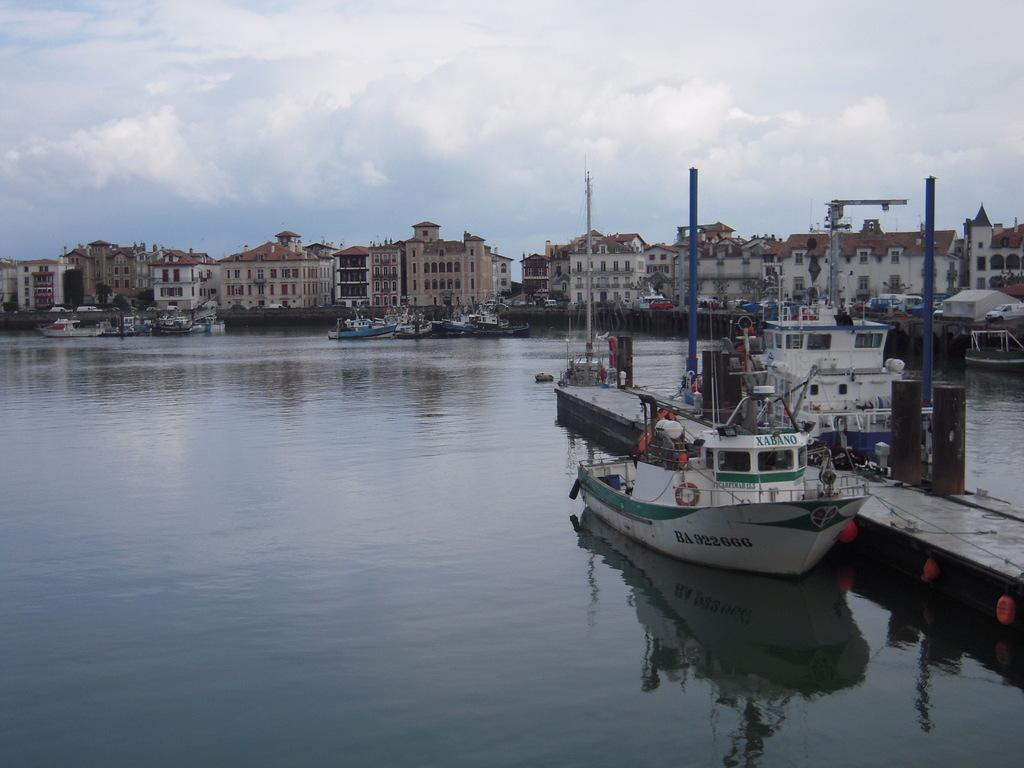<image>
Relay a brief, clear account of the picture shown. White and green ship parked with the numbers 922666 on the side. 